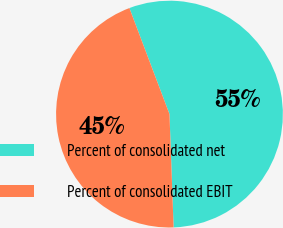<chart> <loc_0><loc_0><loc_500><loc_500><pie_chart><fcel>Percent of consolidated net<fcel>Percent of consolidated EBIT<nl><fcel>55.17%<fcel>44.83%<nl></chart> 